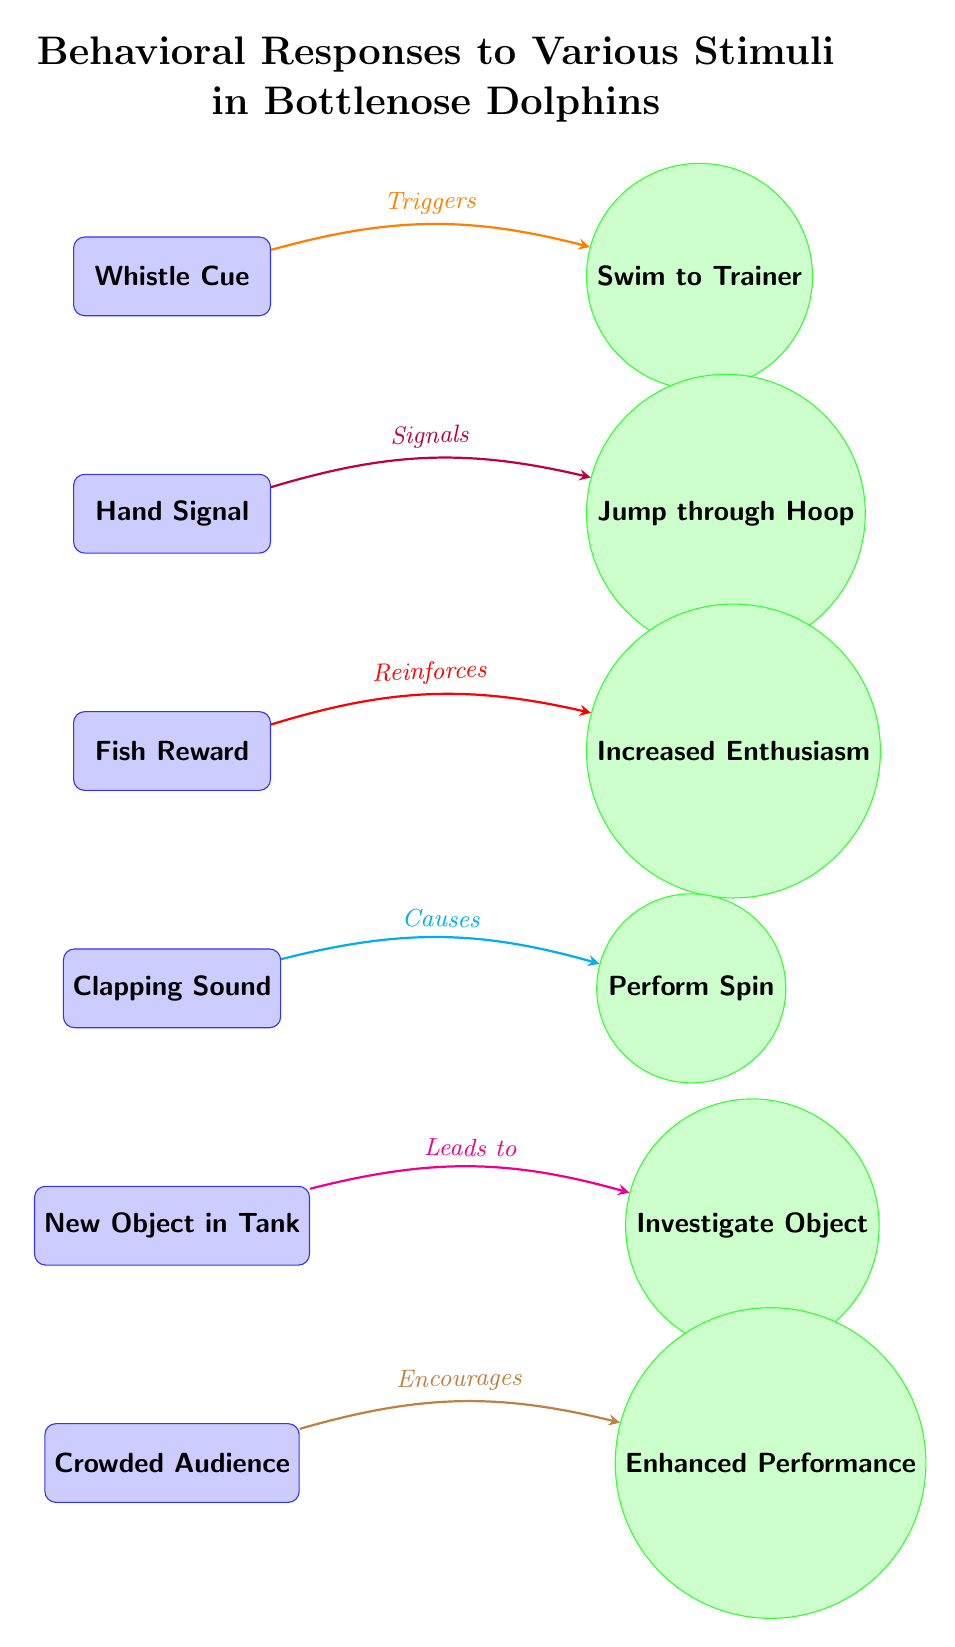What is the first stimulus in the diagram? The first node labeled as a stimulus in the diagram is "Whistle Cue." This can be identified by looking at the topmost stimulus node on the left side of the diagram.
Answer: Whistle Cue How many response nodes are present in the diagram? By counting the circular nodes on the right, there are six response nodes connected to the stimuli, indicating the various reactions bottlenose dolphins exhibit.
Answer: 6 What type of response does the "Fish Reward" stimulus trigger? The "Fish Reward" stimulus corresponds to the response labeled "Increased Enthusiasm." This can be seen by tracing the connection from "Fish Reward" to "Increased Enthusiasm" through the edge labeled "Reinforces."
Answer: Increased Enthusiasm Which stimulus is linked to the "Jump through Hoop" response? The "Hand Signal" stimulus is the one associated with the response "Jump through Hoop," as depicted by the directed edge connecting the two.
Answer: Hand Signal What behavior is exhibited when there is a "Crowded Audience"? The presence of a "Crowded Audience" leads to the response "Enhanced Performance," indicated by the arrow showing the connection and the labeling "Encourages."
Answer: Enhanced Performance What relationship do the "Clapping Sound" and "Perform Spin" have? The "Clapping Sound" acts as a stimulus that, through the connection labeled "Causes," results in the response "Perform Spin." This hierarchical relationship is evident in the diagram.
Answer: Causes Which two stimuli lead to increased activity from dolphins? The stimuli "Whistle Cue" and "Fish Reward" both lead to increased interactions, with "Whistle Cue" triggering "Swim to Trainer" and "Fish Reward" leading to "Increased Enthusiasm." This indicates a pattern of positive behavioral responses.
Answer: Swim to Trainer, Increased Enthusiasm 